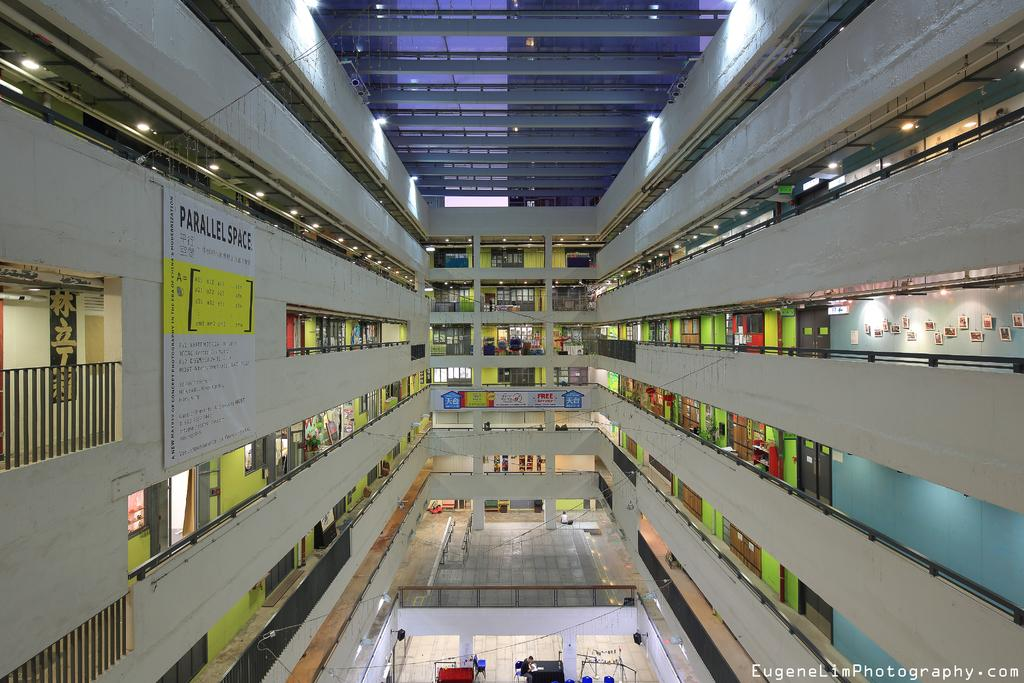What type of location is depicted in the image? The image shows an inside view of a building. What architectural feature can be seen in the image? There are railings visible in the image. What type of establishments are present in the building? There are shops in the image. What can be used to provide illumination in the image? Lights are present in the image. What type of signage is visible in the image? There is a poster with text in the image. Where is the faucet located in the image? There is no faucet present in the image. What type of plastic objects can be seen in the image? There are no plastic objects visible in the image. 